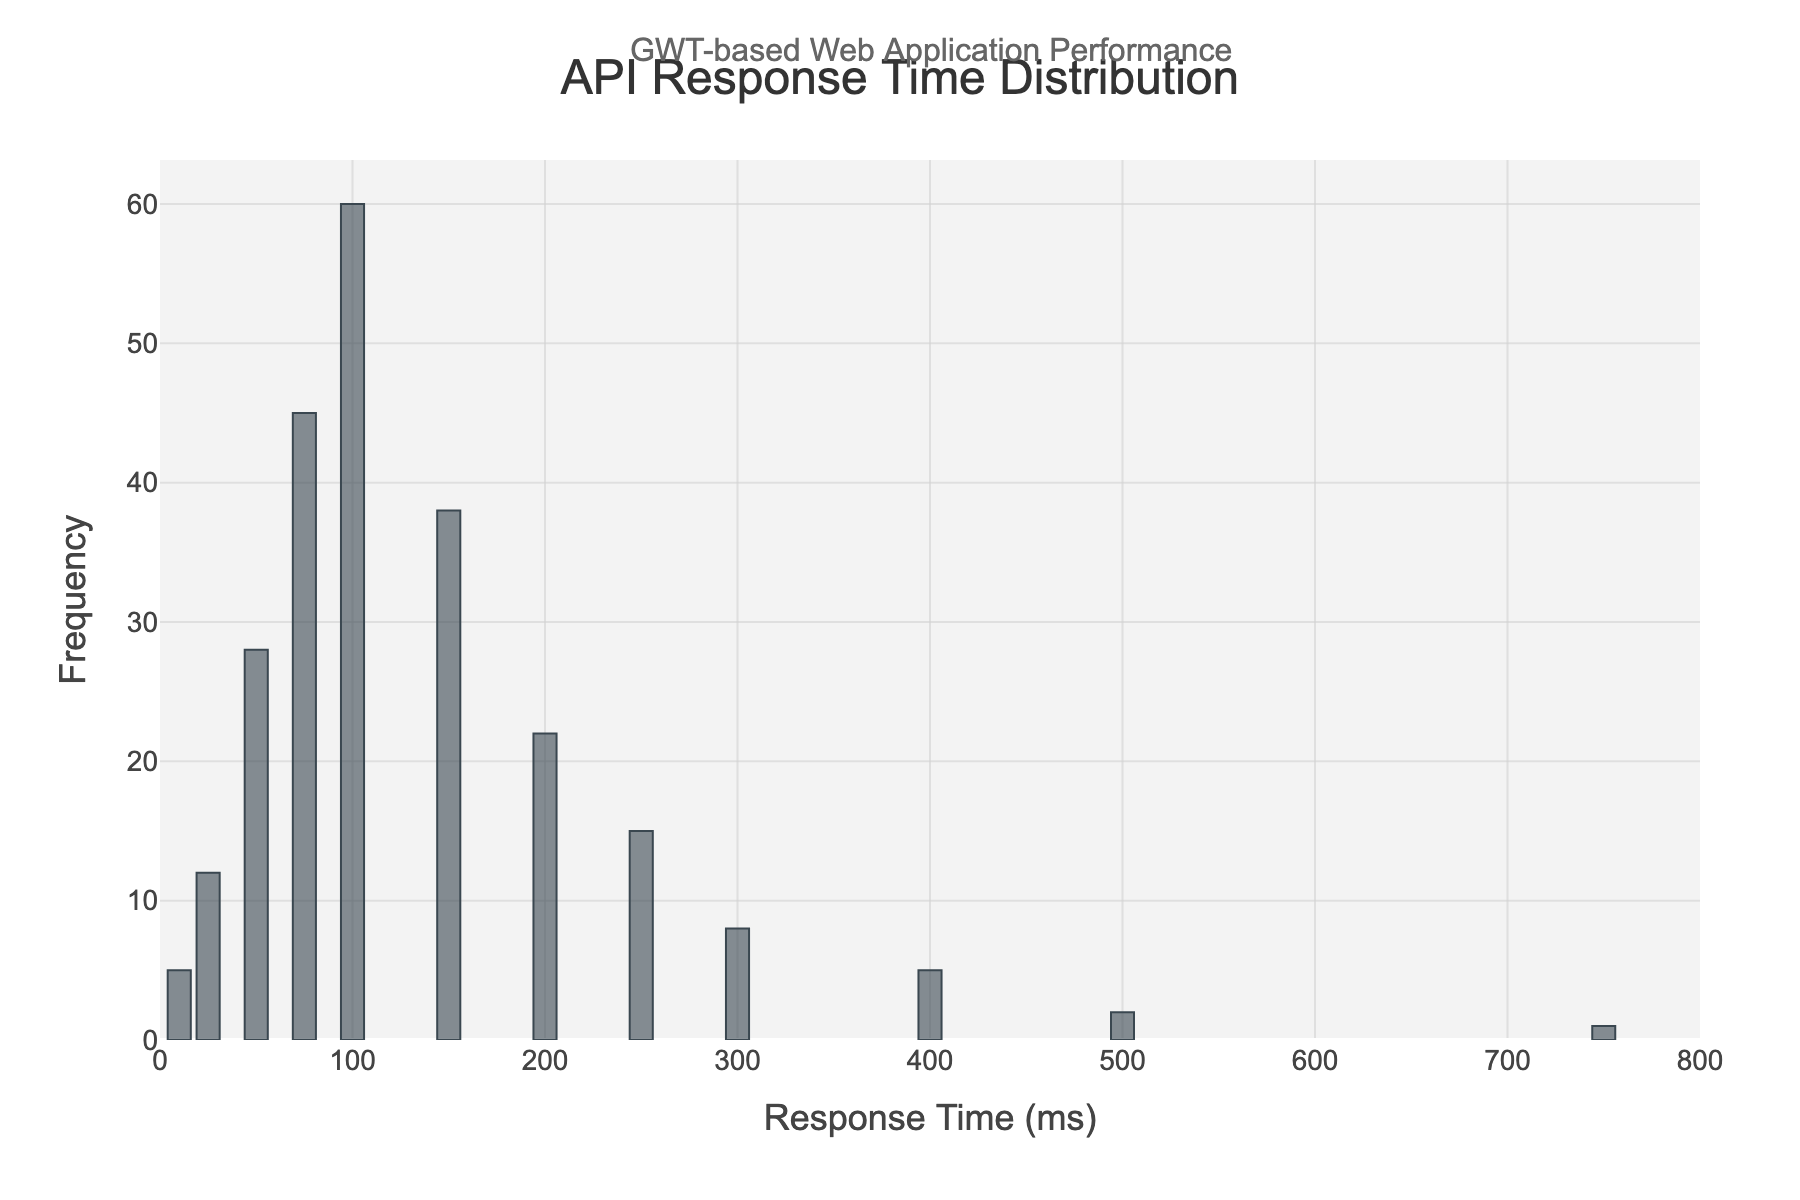What is the title of the histogram? The title text is displayed at the top center of the figure. It reads "API Response Time Distribution".
Answer: API Response Time Distribution What is the frequency of API calls with a response time of 100 ms? To find the frequency, look at the height of the bar corresponding to the 100 ms mark on the x-axis. The label shows 60.
Answer: 60 Which response time range has the highest frequency of API calls? The bar with the greatest height represents the highest frequency, which corresponds to a response time of 100 ms.
Answer: 100 ms How many API calls have a response time of more than 200 ms? To find this, sum the frequencies of all bars with response times over 200 ms: 15 (for 250 ms) + 8 (for 300 ms) + 5 (for 400 ms) + 2 (for 500 ms) + 1 (for 750 ms) = 31.
Answer: 31 What is the total number of API calls plotted in the histogram? Sum up all frequencies from each bar: 5 + 12 + 28 + 45 + 60 + 38 + 22 + 15 + 8 + 5 + 2 + 1 = 241.
Answer: 241 How does the frequency of API calls change as the response time increases from 10 ms to 100 ms? Look at the histogram bars from left to right up to 100 ms. The frequencies increase with each subsequent bar: 5 (10 ms) < 12 (25 ms) < 28 (50 ms) < 45 (75 ms) < 60 (100 ms).
Answer: Increases Which response time has a frequency that is closest to the average frequency of all API calls? First, calculate the average frequency: (5 + 12 + 28 + 45 + 60 + 38 + 22 + 15 + 8 + 5 + 2 + 1) / 12 ≈ 20.08. The closest frequency to 20.08 is 22 (response time of 200 ms).
Answer: 200 ms Compare the frequencies of response times between 50 ms and 150 ms. Which one is higher? By comparing the heights of the bars for 50 ms (28) and 150 ms (38), the one for 150 ms is higher.
Answer: 150 ms Is there a significant drop-off in the frequency of API calls for response times greater than 200 ms? Comparing the heights of bars before and after 200 ms, there is indeed a drop-off: 38 (150 ms) drops to 22 (200 ms) and then 15 (250 ms), and continues to decrease.
Answer: Yes What is the range of response times covered in this histogram? The response times on the x-axis range from 10 ms to 750 ms. The lowest value is 10 ms and the highest is 750 ms.
Answer: 10 ms to 750 ms 